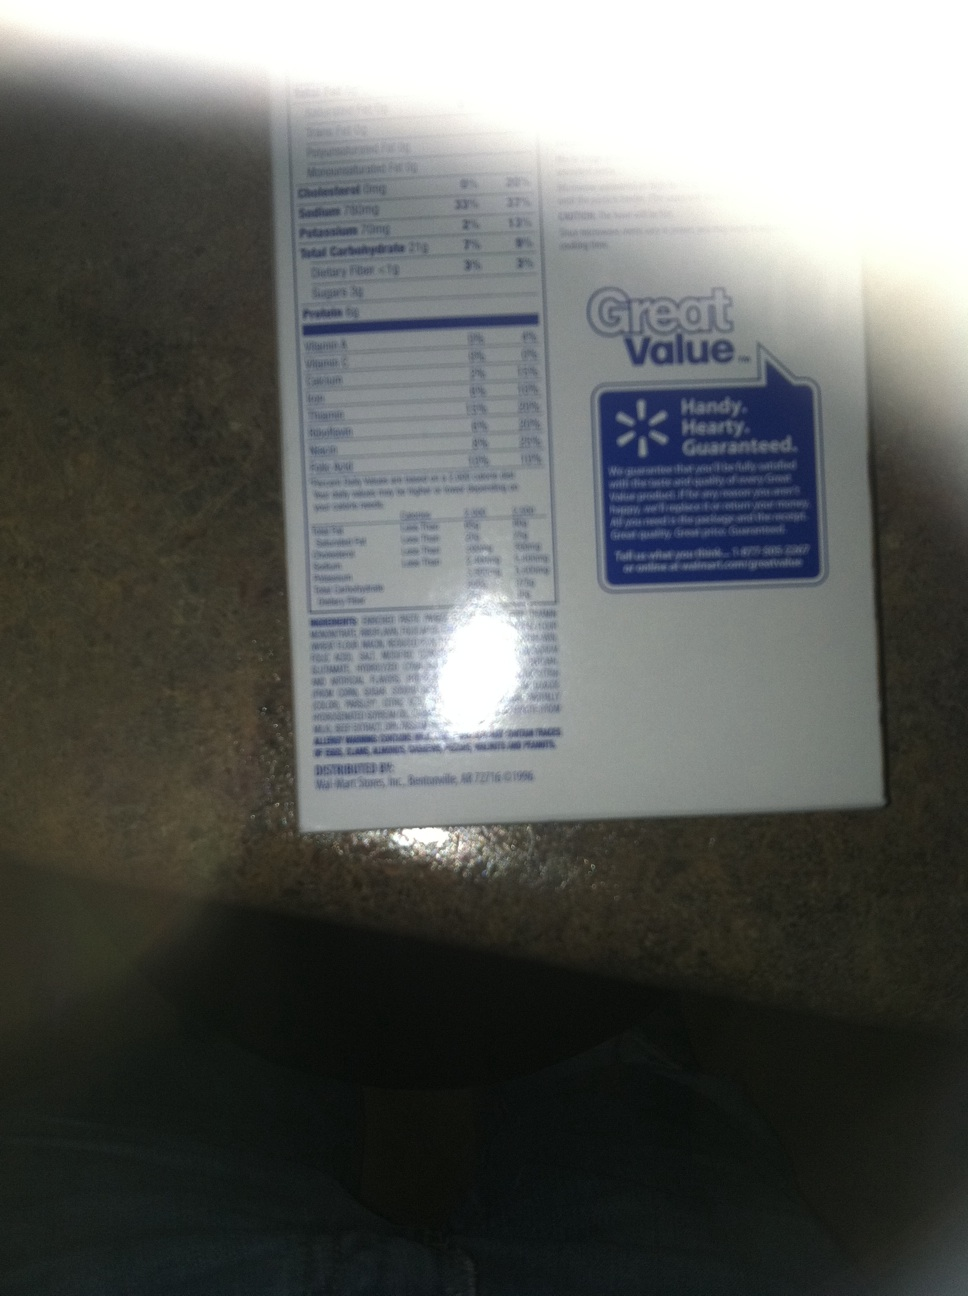What is the significance of the certification badges on this label? The label features a 'Great Value' badge, which represents Walmart's store brand promising value for money. The badge also includes a guarantee of quality, suggesting that the product meets specific standards and if not satisfactory, the purchase price will be refunded or the item replaced. 